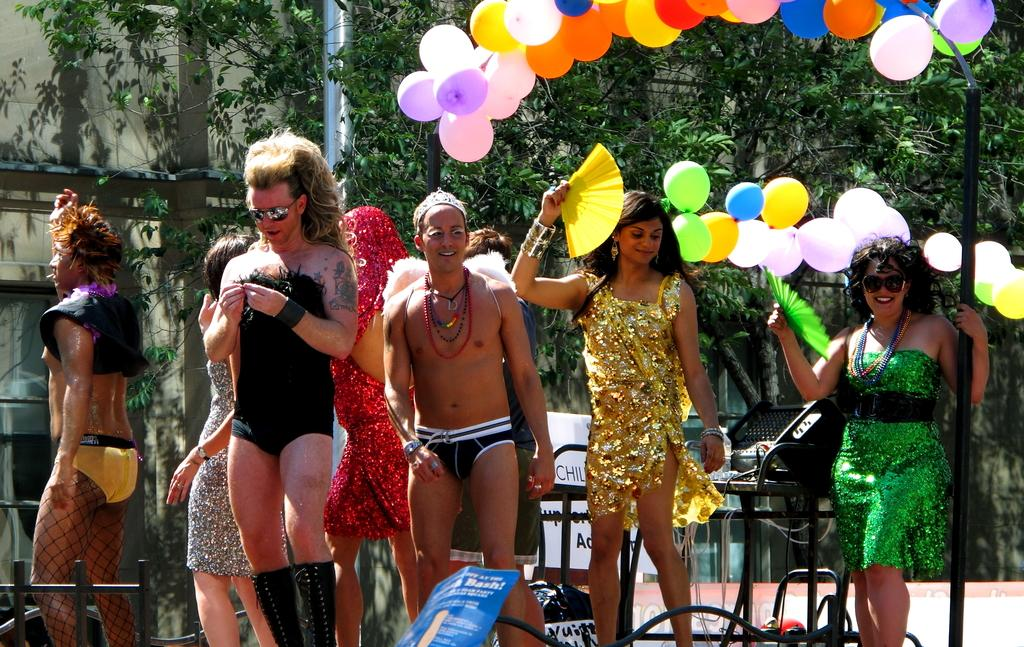What can be seen in the image? There are people standing in the image. What are the people wearing? The people are wearing different types of dresses. What is visible at the top of the image? There are balloons and trees visible at the top of the image. What color are the eyes of the owner of the balloons in the image? There is no owner of the balloons mentioned or visible in the image, and therefore no information about their eyes can be provided. 